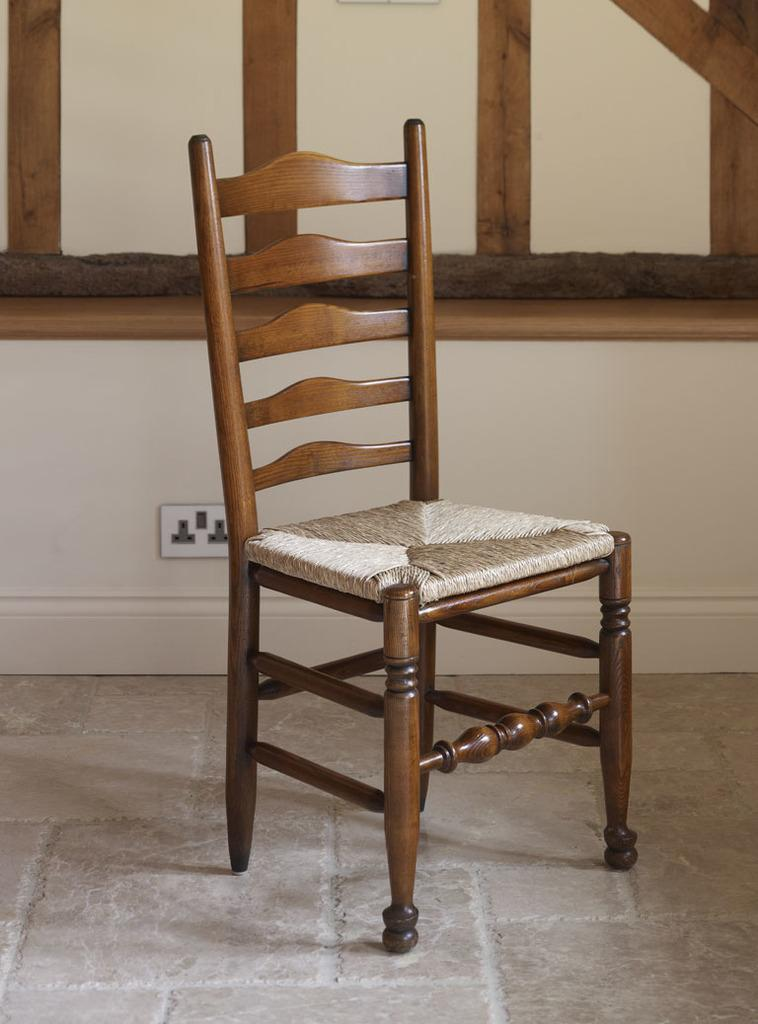What is the main object in the middle of the image? There is a chair in the middle of the image. Where is the chair located? The chair is placed on the floor. What can be seen in the background of the image? There is a window and a switch board attached to the wall in the background. Can you describe the window in the image? The window is on a wall in the background. What type of ticket is hanging from the chair in the image? There is no ticket hanging from the chair in the image. How many stockings are visible on the chair in the image? There are no stockings visible on the chair in the image. 